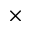Convert formula to latex. <formula><loc_0><loc_0><loc_500><loc_500>\times</formula> 